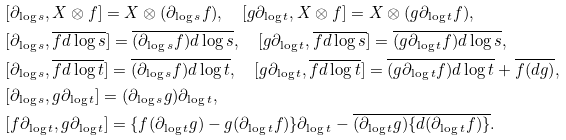Convert formula to latex. <formula><loc_0><loc_0><loc_500><loc_500>& [ \partial _ { \log s } , X \otimes f ] = X \otimes ( \partial _ { \log s } f ) , \quad [ g \partial _ { \log t } , X \otimes f ] = X \otimes ( g \partial _ { \log t } f ) , \\ & [ \partial _ { \log s } , \overline { f d \log s } ] = \overline { ( \partial _ { \log s } f ) d \log s } , \quad [ g \partial _ { \log t } , \overline { f d \log s } ] = \overline { ( g \partial _ { \log t } f ) d \log s } , \\ & [ \partial _ { \log s } , \overline { f d \log t } ] = \overline { ( \partial _ { \log s } f ) d \log t } , \quad [ g \partial _ { \log t } , \overline { f d \log t } ] = \overline { ( g \partial _ { \log t } f ) d \log t } + \overline { f ( d g ) } , \\ & [ \partial _ { \log s } , g \partial _ { \log t } ] = ( \partial _ { \log s } g ) \partial _ { \log t } , \\ & [ f \partial _ { \log t } , g \partial _ { \log t } ] = \{ f ( \partial _ { \log t } g ) - g ( \partial _ { \log t } f ) \} \partial _ { \log t } - \overline { ( \partial _ { \log t } g ) \{ d ( \partial _ { \log t } f ) \} } .</formula> 